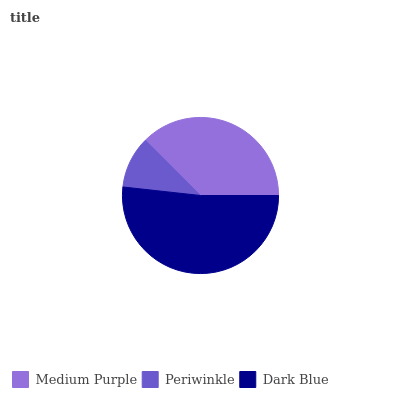Is Periwinkle the minimum?
Answer yes or no. Yes. Is Dark Blue the maximum?
Answer yes or no. Yes. Is Dark Blue the minimum?
Answer yes or no. No. Is Periwinkle the maximum?
Answer yes or no. No. Is Dark Blue greater than Periwinkle?
Answer yes or no. Yes. Is Periwinkle less than Dark Blue?
Answer yes or no. Yes. Is Periwinkle greater than Dark Blue?
Answer yes or no. No. Is Dark Blue less than Periwinkle?
Answer yes or no. No. Is Medium Purple the high median?
Answer yes or no. Yes. Is Medium Purple the low median?
Answer yes or no. Yes. Is Dark Blue the high median?
Answer yes or no. No. Is Periwinkle the low median?
Answer yes or no. No. 